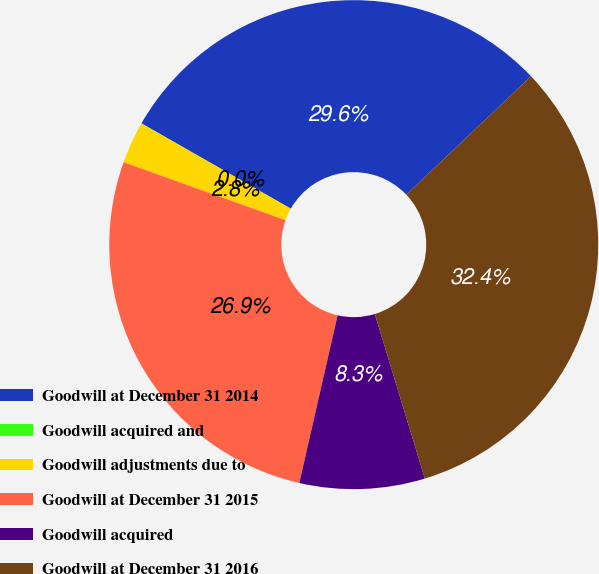<chart> <loc_0><loc_0><loc_500><loc_500><pie_chart><fcel>Goodwill at December 31 2014<fcel>Goodwill acquired and<fcel>Goodwill adjustments due to<fcel>Goodwill at December 31 2015<fcel>Goodwill acquired<fcel>Goodwill at December 31 2016<nl><fcel>29.65%<fcel>0.02%<fcel>2.77%<fcel>26.9%<fcel>8.27%<fcel>32.4%<nl></chart> 